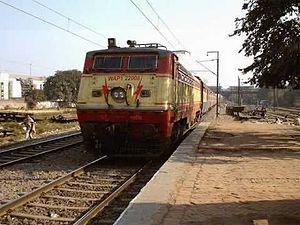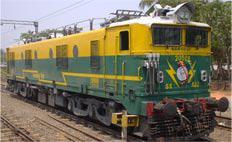The first image is the image on the left, the second image is the image on the right. Given the left and right images, does the statement "In one image a train locomotive at the front is painted in different two-tone colors than the one or more train cars that are behind it." hold true? Answer yes or no. No. The first image is the image on the left, the second image is the image on the right. Examine the images to the left and right. Is the description "Both trains are moving toward the right." accurate? Answer yes or no. No. 